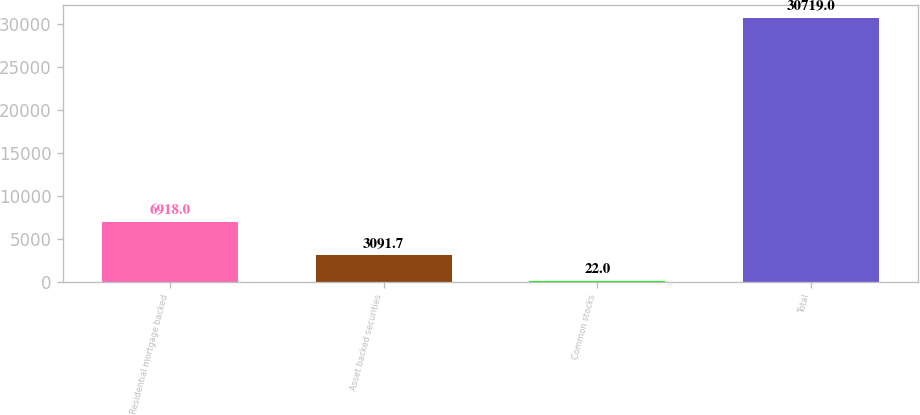<chart> <loc_0><loc_0><loc_500><loc_500><bar_chart><fcel>Residential mortgage backed<fcel>Asset backed securities<fcel>Common stocks<fcel>Total<nl><fcel>6918<fcel>3091.7<fcel>22<fcel>30719<nl></chart> 